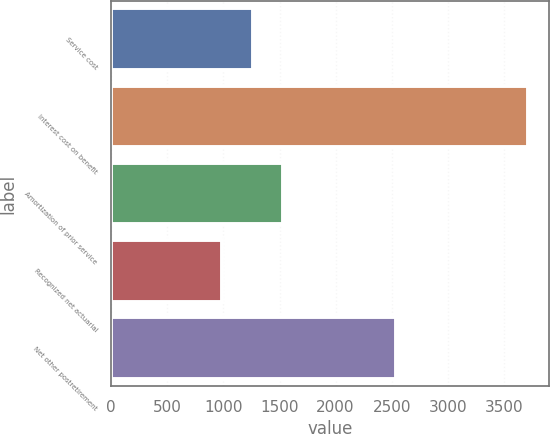Convert chart to OTSL. <chart><loc_0><loc_0><loc_500><loc_500><bar_chart><fcel>Service cost<fcel>Interest cost on benefit<fcel>Amortization of prior service<fcel>Recognized net actuarial<fcel>Net other postretirement<nl><fcel>1260.8<fcel>3716<fcel>1533.6<fcel>988<fcel>2541<nl></chart> 